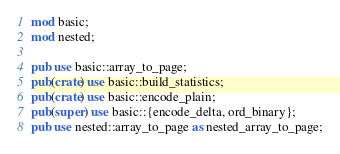<code> <loc_0><loc_0><loc_500><loc_500><_Rust_>mod basic;
mod nested;

pub use basic::array_to_page;
pub(crate) use basic::build_statistics;
pub(crate) use basic::encode_plain;
pub(super) use basic::{encode_delta, ord_binary};
pub use nested::array_to_page as nested_array_to_page;
</code> 